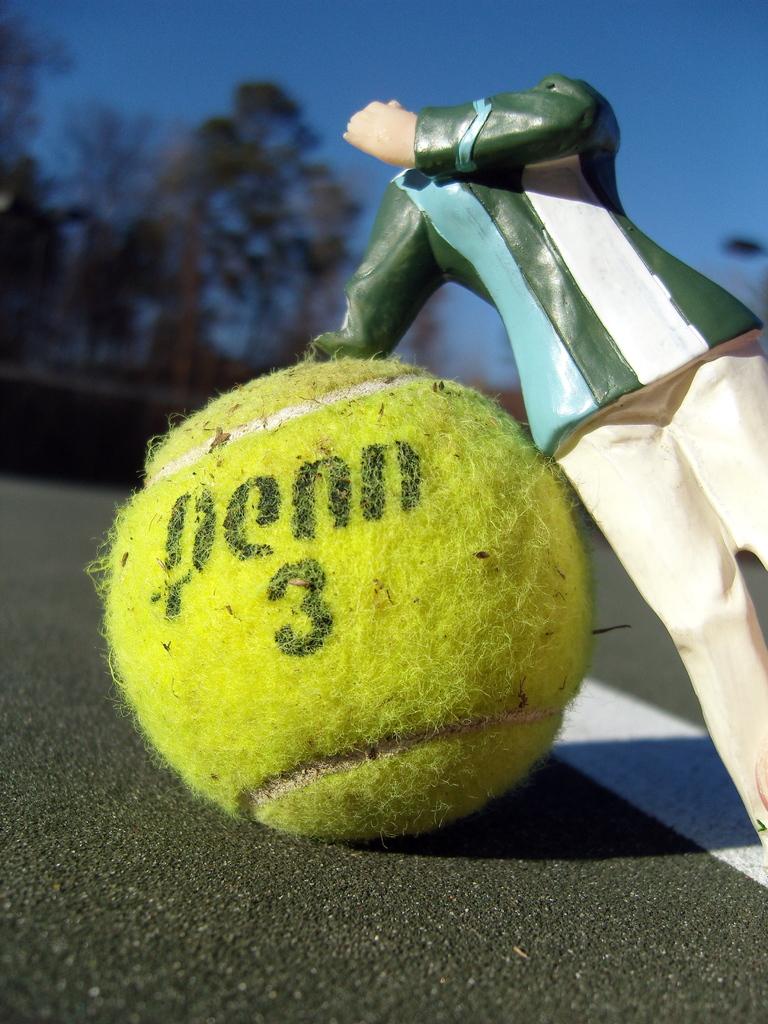What is on the tennis ball?
Ensure brevity in your answer.  Penn 3. 